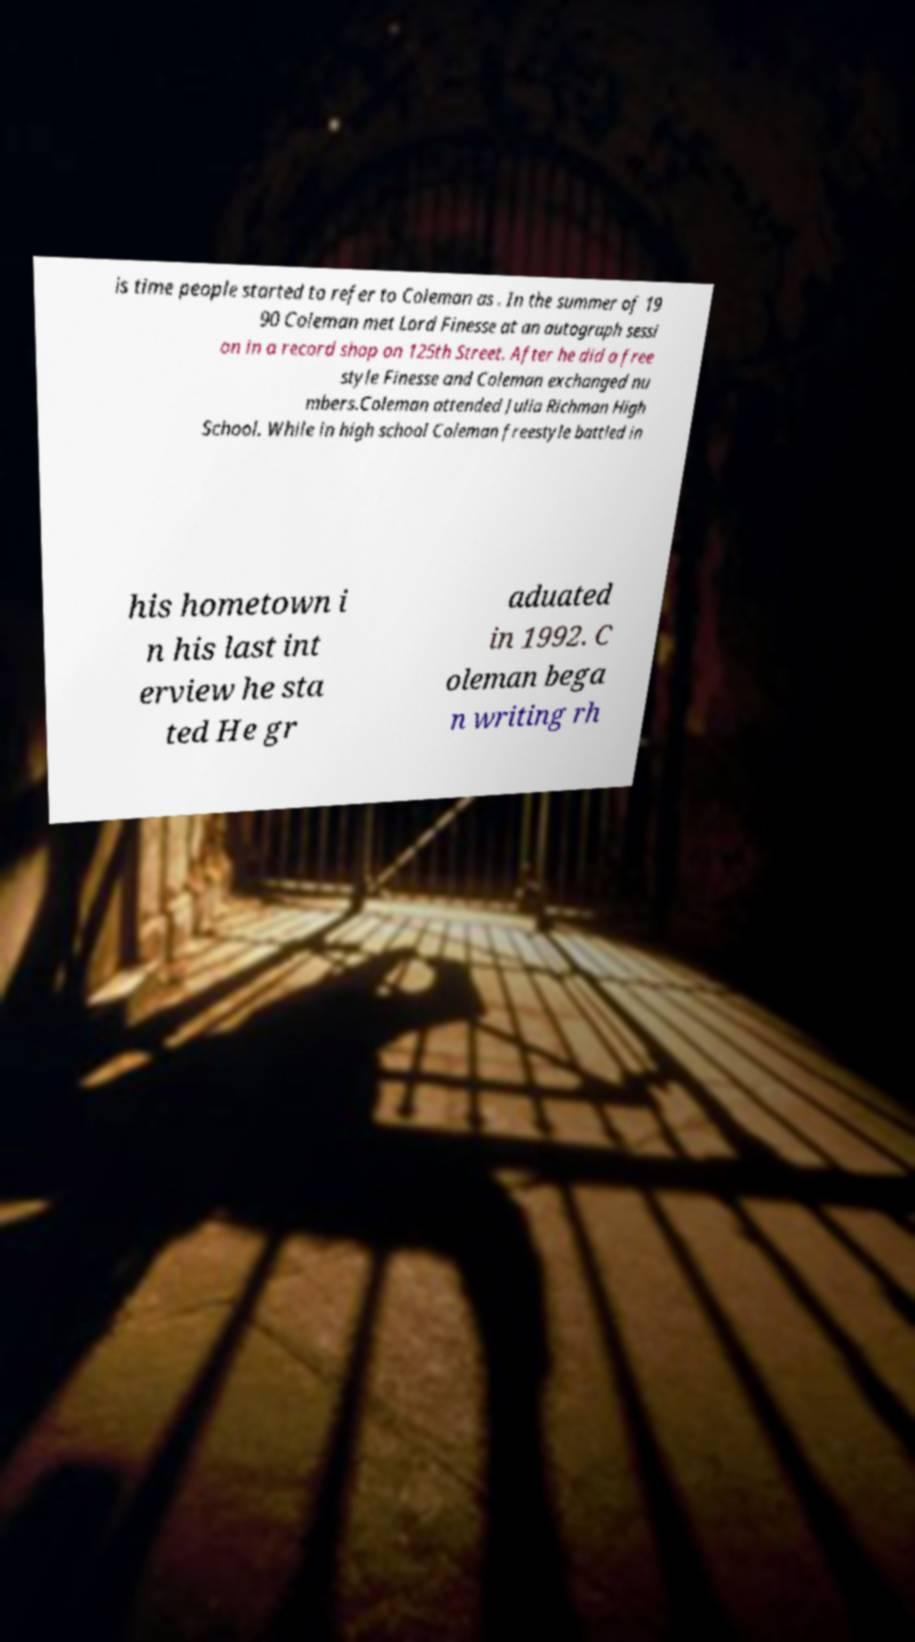Please identify and transcribe the text found in this image. is time people started to refer to Coleman as . In the summer of 19 90 Coleman met Lord Finesse at an autograph sessi on in a record shop on 125th Street. After he did a free style Finesse and Coleman exchanged nu mbers.Coleman attended Julia Richman High School. While in high school Coleman freestyle battled in his hometown i n his last int erview he sta ted He gr aduated in 1992. C oleman bega n writing rh 